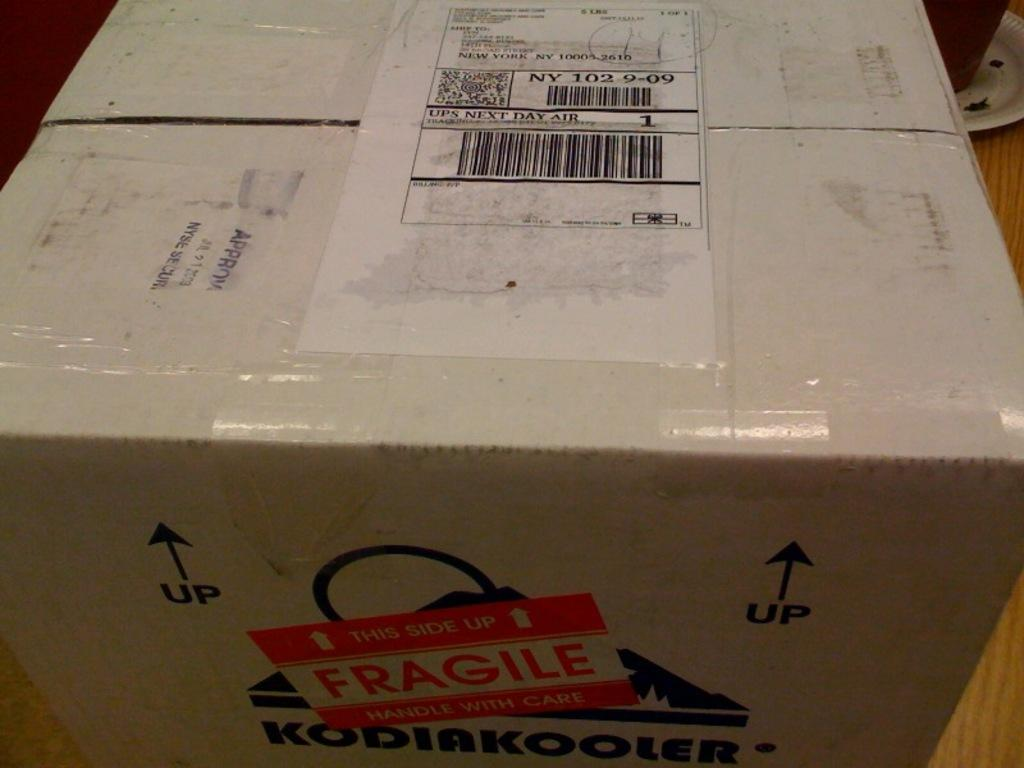<image>
Write a terse but informative summary of the picture. A box shipped from KodiakKooler is marked fragile. 